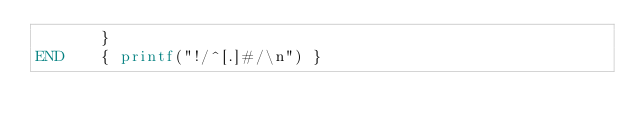<code> <loc_0><loc_0><loc_500><loc_500><_Awk_>       }
END    { printf("!/^[.]#/\n") }
</code> 